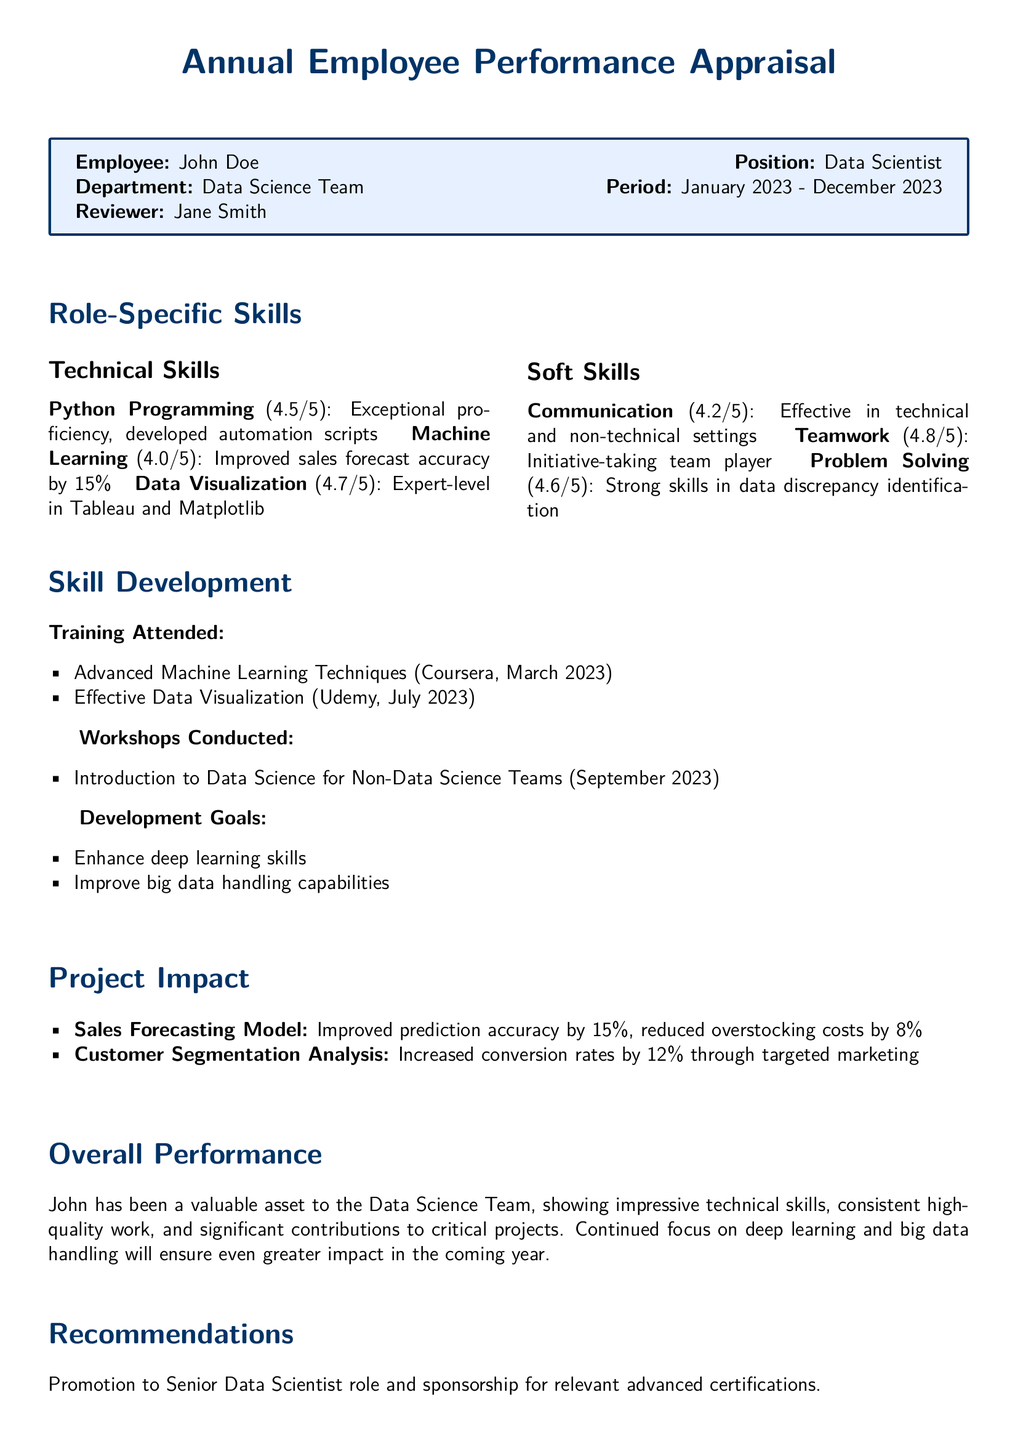What is the employee's name? The employee's name is mentioned in the document header, "John Doe."
Answer: John Doe Who is the reviewer? The reviewer is specified in the document, "Jane Smith."
Answer: Jane Smith Which training was attended in March 2023? The document lists "Advanced Machine Learning Techniques" as the training attended in March 2023.
Answer: Advanced Machine Learning Techniques What score did John receive for Teamwork? The score for Teamwork is stated in the skills section of the document, which is "4.8."
Answer: 4.8 What percentage did the sales forecast accuracy improve by? The project impact section details that the sales forecasting model improved prediction accuracy by "15%."
Answer: 15% What is one of the development goals mentioned? The document lists development goals, including "Enhance deep learning skills."
Answer: Enhance deep learning skills What was the impact of the Customer Segmentation Analysis? The project impact section mentions that it increased conversion rates by "12%."
Answer: 12% What position is John recommended for? The recommendations section of the document states that John is recommended for promotion to "Senior Data Scientist."
Answer: Senior Data Scientist How many workshops did John conduct? The document lists one workshop conducted, "Introduction to Data Science for Non-Data Science Teams."
Answer: One 